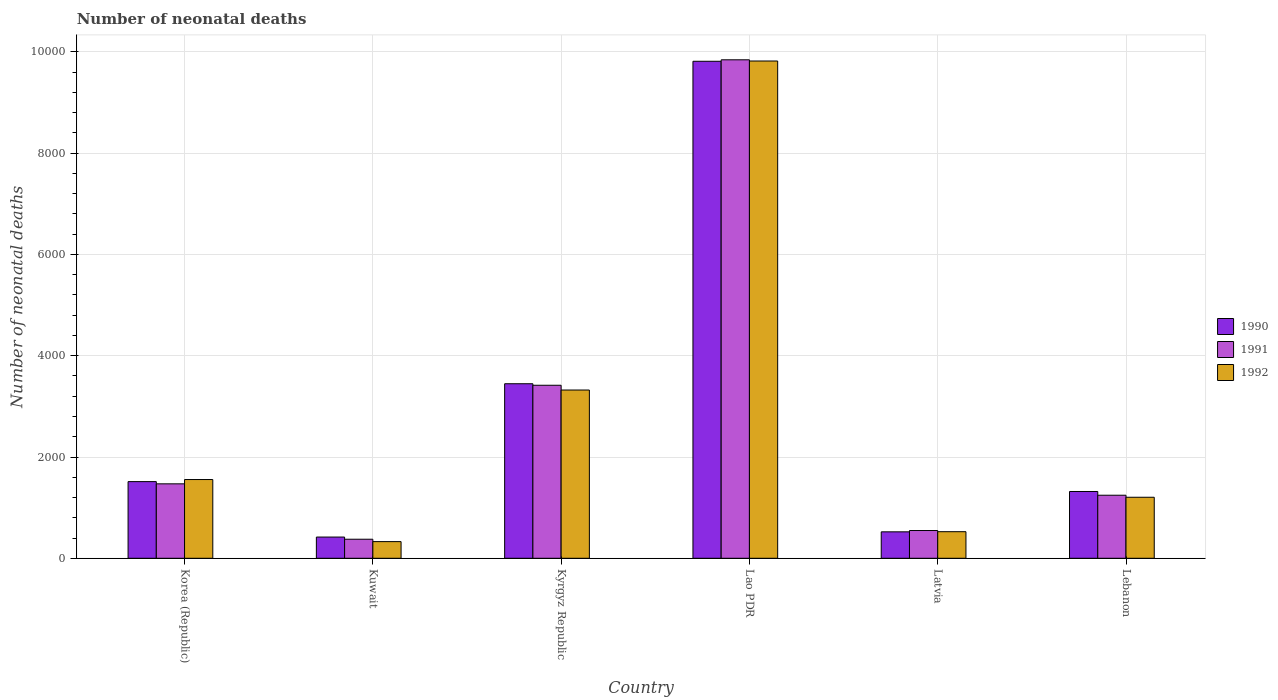How many different coloured bars are there?
Offer a terse response. 3. How many groups of bars are there?
Offer a terse response. 6. How many bars are there on the 4th tick from the left?
Make the answer very short. 3. How many bars are there on the 4th tick from the right?
Keep it short and to the point. 3. What is the label of the 5th group of bars from the left?
Your answer should be compact. Latvia. In how many cases, is the number of bars for a given country not equal to the number of legend labels?
Offer a terse response. 0. What is the number of neonatal deaths in in 1990 in Kyrgyz Republic?
Keep it short and to the point. 3447. Across all countries, what is the maximum number of neonatal deaths in in 1990?
Offer a very short reply. 9816. Across all countries, what is the minimum number of neonatal deaths in in 1992?
Your answer should be compact. 329. In which country was the number of neonatal deaths in in 1992 maximum?
Provide a short and direct response. Lao PDR. In which country was the number of neonatal deaths in in 1992 minimum?
Provide a short and direct response. Kuwait. What is the total number of neonatal deaths in in 1992 in the graph?
Keep it short and to the point. 1.68e+04. What is the difference between the number of neonatal deaths in in 1992 in Korea (Republic) and that in Latvia?
Offer a terse response. 1030. What is the difference between the number of neonatal deaths in in 1991 in Lao PDR and the number of neonatal deaths in in 1992 in Kyrgyz Republic?
Provide a succinct answer. 6522. What is the average number of neonatal deaths in in 1991 per country?
Provide a short and direct response. 2816.83. What is the difference between the number of neonatal deaths in of/in 1991 and number of neonatal deaths in of/in 1992 in Kyrgyz Republic?
Keep it short and to the point. 94. In how many countries, is the number of neonatal deaths in in 1992 greater than 4000?
Ensure brevity in your answer.  1. What is the ratio of the number of neonatal deaths in in 1990 in Korea (Republic) to that in Latvia?
Ensure brevity in your answer.  2.9. Is the difference between the number of neonatal deaths in in 1991 in Korea (Republic) and Kuwait greater than the difference between the number of neonatal deaths in in 1992 in Korea (Republic) and Kuwait?
Ensure brevity in your answer.  No. What is the difference between the highest and the second highest number of neonatal deaths in in 1990?
Keep it short and to the point. 8302. What is the difference between the highest and the lowest number of neonatal deaths in in 1991?
Provide a succinct answer. 9469. What does the 3rd bar from the right in Latvia represents?
Keep it short and to the point. 1990. Is it the case that in every country, the sum of the number of neonatal deaths in in 1990 and number of neonatal deaths in in 1992 is greater than the number of neonatal deaths in in 1991?
Your answer should be compact. Yes. How many bars are there?
Provide a succinct answer. 18. Are all the bars in the graph horizontal?
Your response must be concise. No. How many countries are there in the graph?
Your answer should be compact. 6. Does the graph contain any zero values?
Offer a terse response. No. What is the title of the graph?
Your answer should be compact. Number of neonatal deaths. Does "2006" appear as one of the legend labels in the graph?
Provide a short and direct response. No. What is the label or title of the X-axis?
Provide a succinct answer. Country. What is the label or title of the Y-axis?
Give a very brief answer. Number of neonatal deaths. What is the Number of neonatal deaths of 1990 in Korea (Republic)?
Make the answer very short. 1514. What is the Number of neonatal deaths in 1991 in Korea (Republic)?
Ensure brevity in your answer.  1470. What is the Number of neonatal deaths of 1992 in Korea (Republic)?
Provide a short and direct response. 1555. What is the Number of neonatal deaths of 1990 in Kuwait?
Ensure brevity in your answer.  419. What is the Number of neonatal deaths in 1991 in Kuwait?
Ensure brevity in your answer.  376. What is the Number of neonatal deaths in 1992 in Kuwait?
Offer a very short reply. 329. What is the Number of neonatal deaths of 1990 in Kyrgyz Republic?
Your answer should be very brief. 3447. What is the Number of neonatal deaths in 1991 in Kyrgyz Republic?
Your response must be concise. 3417. What is the Number of neonatal deaths of 1992 in Kyrgyz Republic?
Provide a short and direct response. 3323. What is the Number of neonatal deaths in 1990 in Lao PDR?
Provide a succinct answer. 9816. What is the Number of neonatal deaths in 1991 in Lao PDR?
Ensure brevity in your answer.  9845. What is the Number of neonatal deaths in 1992 in Lao PDR?
Provide a succinct answer. 9821. What is the Number of neonatal deaths in 1990 in Latvia?
Your response must be concise. 522. What is the Number of neonatal deaths in 1991 in Latvia?
Make the answer very short. 548. What is the Number of neonatal deaths in 1992 in Latvia?
Provide a short and direct response. 525. What is the Number of neonatal deaths in 1990 in Lebanon?
Make the answer very short. 1319. What is the Number of neonatal deaths of 1991 in Lebanon?
Provide a short and direct response. 1245. What is the Number of neonatal deaths of 1992 in Lebanon?
Offer a terse response. 1205. Across all countries, what is the maximum Number of neonatal deaths in 1990?
Your answer should be compact. 9816. Across all countries, what is the maximum Number of neonatal deaths in 1991?
Provide a succinct answer. 9845. Across all countries, what is the maximum Number of neonatal deaths in 1992?
Your answer should be very brief. 9821. Across all countries, what is the minimum Number of neonatal deaths in 1990?
Keep it short and to the point. 419. Across all countries, what is the minimum Number of neonatal deaths in 1991?
Give a very brief answer. 376. Across all countries, what is the minimum Number of neonatal deaths in 1992?
Offer a terse response. 329. What is the total Number of neonatal deaths in 1990 in the graph?
Your answer should be very brief. 1.70e+04. What is the total Number of neonatal deaths of 1991 in the graph?
Ensure brevity in your answer.  1.69e+04. What is the total Number of neonatal deaths in 1992 in the graph?
Your answer should be compact. 1.68e+04. What is the difference between the Number of neonatal deaths of 1990 in Korea (Republic) and that in Kuwait?
Keep it short and to the point. 1095. What is the difference between the Number of neonatal deaths in 1991 in Korea (Republic) and that in Kuwait?
Provide a succinct answer. 1094. What is the difference between the Number of neonatal deaths in 1992 in Korea (Republic) and that in Kuwait?
Ensure brevity in your answer.  1226. What is the difference between the Number of neonatal deaths of 1990 in Korea (Republic) and that in Kyrgyz Republic?
Make the answer very short. -1933. What is the difference between the Number of neonatal deaths of 1991 in Korea (Republic) and that in Kyrgyz Republic?
Offer a very short reply. -1947. What is the difference between the Number of neonatal deaths of 1992 in Korea (Republic) and that in Kyrgyz Republic?
Your answer should be compact. -1768. What is the difference between the Number of neonatal deaths of 1990 in Korea (Republic) and that in Lao PDR?
Your response must be concise. -8302. What is the difference between the Number of neonatal deaths in 1991 in Korea (Republic) and that in Lao PDR?
Offer a very short reply. -8375. What is the difference between the Number of neonatal deaths of 1992 in Korea (Republic) and that in Lao PDR?
Make the answer very short. -8266. What is the difference between the Number of neonatal deaths of 1990 in Korea (Republic) and that in Latvia?
Offer a very short reply. 992. What is the difference between the Number of neonatal deaths of 1991 in Korea (Republic) and that in Latvia?
Provide a succinct answer. 922. What is the difference between the Number of neonatal deaths in 1992 in Korea (Republic) and that in Latvia?
Your response must be concise. 1030. What is the difference between the Number of neonatal deaths in 1990 in Korea (Republic) and that in Lebanon?
Offer a very short reply. 195. What is the difference between the Number of neonatal deaths in 1991 in Korea (Republic) and that in Lebanon?
Give a very brief answer. 225. What is the difference between the Number of neonatal deaths of 1992 in Korea (Republic) and that in Lebanon?
Keep it short and to the point. 350. What is the difference between the Number of neonatal deaths of 1990 in Kuwait and that in Kyrgyz Republic?
Make the answer very short. -3028. What is the difference between the Number of neonatal deaths in 1991 in Kuwait and that in Kyrgyz Republic?
Your response must be concise. -3041. What is the difference between the Number of neonatal deaths in 1992 in Kuwait and that in Kyrgyz Republic?
Keep it short and to the point. -2994. What is the difference between the Number of neonatal deaths of 1990 in Kuwait and that in Lao PDR?
Give a very brief answer. -9397. What is the difference between the Number of neonatal deaths of 1991 in Kuwait and that in Lao PDR?
Give a very brief answer. -9469. What is the difference between the Number of neonatal deaths in 1992 in Kuwait and that in Lao PDR?
Your answer should be compact. -9492. What is the difference between the Number of neonatal deaths of 1990 in Kuwait and that in Latvia?
Offer a terse response. -103. What is the difference between the Number of neonatal deaths of 1991 in Kuwait and that in Latvia?
Make the answer very short. -172. What is the difference between the Number of neonatal deaths of 1992 in Kuwait and that in Latvia?
Ensure brevity in your answer.  -196. What is the difference between the Number of neonatal deaths in 1990 in Kuwait and that in Lebanon?
Ensure brevity in your answer.  -900. What is the difference between the Number of neonatal deaths of 1991 in Kuwait and that in Lebanon?
Your answer should be very brief. -869. What is the difference between the Number of neonatal deaths in 1992 in Kuwait and that in Lebanon?
Offer a very short reply. -876. What is the difference between the Number of neonatal deaths of 1990 in Kyrgyz Republic and that in Lao PDR?
Provide a short and direct response. -6369. What is the difference between the Number of neonatal deaths in 1991 in Kyrgyz Republic and that in Lao PDR?
Offer a very short reply. -6428. What is the difference between the Number of neonatal deaths of 1992 in Kyrgyz Republic and that in Lao PDR?
Keep it short and to the point. -6498. What is the difference between the Number of neonatal deaths of 1990 in Kyrgyz Republic and that in Latvia?
Ensure brevity in your answer.  2925. What is the difference between the Number of neonatal deaths in 1991 in Kyrgyz Republic and that in Latvia?
Provide a succinct answer. 2869. What is the difference between the Number of neonatal deaths in 1992 in Kyrgyz Republic and that in Latvia?
Your answer should be compact. 2798. What is the difference between the Number of neonatal deaths of 1990 in Kyrgyz Republic and that in Lebanon?
Make the answer very short. 2128. What is the difference between the Number of neonatal deaths of 1991 in Kyrgyz Republic and that in Lebanon?
Offer a very short reply. 2172. What is the difference between the Number of neonatal deaths in 1992 in Kyrgyz Republic and that in Lebanon?
Your answer should be compact. 2118. What is the difference between the Number of neonatal deaths in 1990 in Lao PDR and that in Latvia?
Provide a succinct answer. 9294. What is the difference between the Number of neonatal deaths in 1991 in Lao PDR and that in Latvia?
Make the answer very short. 9297. What is the difference between the Number of neonatal deaths of 1992 in Lao PDR and that in Latvia?
Your answer should be very brief. 9296. What is the difference between the Number of neonatal deaths of 1990 in Lao PDR and that in Lebanon?
Your response must be concise. 8497. What is the difference between the Number of neonatal deaths in 1991 in Lao PDR and that in Lebanon?
Your answer should be compact. 8600. What is the difference between the Number of neonatal deaths of 1992 in Lao PDR and that in Lebanon?
Offer a very short reply. 8616. What is the difference between the Number of neonatal deaths of 1990 in Latvia and that in Lebanon?
Keep it short and to the point. -797. What is the difference between the Number of neonatal deaths of 1991 in Latvia and that in Lebanon?
Your answer should be compact. -697. What is the difference between the Number of neonatal deaths of 1992 in Latvia and that in Lebanon?
Give a very brief answer. -680. What is the difference between the Number of neonatal deaths in 1990 in Korea (Republic) and the Number of neonatal deaths in 1991 in Kuwait?
Offer a very short reply. 1138. What is the difference between the Number of neonatal deaths in 1990 in Korea (Republic) and the Number of neonatal deaths in 1992 in Kuwait?
Keep it short and to the point. 1185. What is the difference between the Number of neonatal deaths of 1991 in Korea (Republic) and the Number of neonatal deaths of 1992 in Kuwait?
Give a very brief answer. 1141. What is the difference between the Number of neonatal deaths of 1990 in Korea (Republic) and the Number of neonatal deaths of 1991 in Kyrgyz Republic?
Provide a succinct answer. -1903. What is the difference between the Number of neonatal deaths of 1990 in Korea (Republic) and the Number of neonatal deaths of 1992 in Kyrgyz Republic?
Make the answer very short. -1809. What is the difference between the Number of neonatal deaths of 1991 in Korea (Republic) and the Number of neonatal deaths of 1992 in Kyrgyz Republic?
Your answer should be compact. -1853. What is the difference between the Number of neonatal deaths of 1990 in Korea (Republic) and the Number of neonatal deaths of 1991 in Lao PDR?
Your answer should be compact. -8331. What is the difference between the Number of neonatal deaths in 1990 in Korea (Republic) and the Number of neonatal deaths in 1992 in Lao PDR?
Keep it short and to the point. -8307. What is the difference between the Number of neonatal deaths of 1991 in Korea (Republic) and the Number of neonatal deaths of 1992 in Lao PDR?
Keep it short and to the point. -8351. What is the difference between the Number of neonatal deaths in 1990 in Korea (Republic) and the Number of neonatal deaths in 1991 in Latvia?
Make the answer very short. 966. What is the difference between the Number of neonatal deaths in 1990 in Korea (Republic) and the Number of neonatal deaths in 1992 in Latvia?
Keep it short and to the point. 989. What is the difference between the Number of neonatal deaths of 1991 in Korea (Republic) and the Number of neonatal deaths of 1992 in Latvia?
Your response must be concise. 945. What is the difference between the Number of neonatal deaths in 1990 in Korea (Republic) and the Number of neonatal deaths in 1991 in Lebanon?
Keep it short and to the point. 269. What is the difference between the Number of neonatal deaths in 1990 in Korea (Republic) and the Number of neonatal deaths in 1992 in Lebanon?
Provide a succinct answer. 309. What is the difference between the Number of neonatal deaths in 1991 in Korea (Republic) and the Number of neonatal deaths in 1992 in Lebanon?
Give a very brief answer. 265. What is the difference between the Number of neonatal deaths in 1990 in Kuwait and the Number of neonatal deaths in 1991 in Kyrgyz Republic?
Provide a short and direct response. -2998. What is the difference between the Number of neonatal deaths of 1990 in Kuwait and the Number of neonatal deaths of 1992 in Kyrgyz Republic?
Offer a very short reply. -2904. What is the difference between the Number of neonatal deaths of 1991 in Kuwait and the Number of neonatal deaths of 1992 in Kyrgyz Republic?
Your answer should be compact. -2947. What is the difference between the Number of neonatal deaths of 1990 in Kuwait and the Number of neonatal deaths of 1991 in Lao PDR?
Offer a terse response. -9426. What is the difference between the Number of neonatal deaths in 1990 in Kuwait and the Number of neonatal deaths in 1992 in Lao PDR?
Give a very brief answer. -9402. What is the difference between the Number of neonatal deaths of 1991 in Kuwait and the Number of neonatal deaths of 1992 in Lao PDR?
Offer a very short reply. -9445. What is the difference between the Number of neonatal deaths in 1990 in Kuwait and the Number of neonatal deaths in 1991 in Latvia?
Your response must be concise. -129. What is the difference between the Number of neonatal deaths of 1990 in Kuwait and the Number of neonatal deaths of 1992 in Latvia?
Your response must be concise. -106. What is the difference between the Number of neonatal deaths of 1991 in Kuwait and the Number of neonatal deaths of 1992 in Latvia?
Your answer should be very brief. -149. What is the difference between the Number of neonatal deaths in 1990 in Kuwait and the Number of neonatal deaths in 1991 in Lebanon?
Your response must be concise. -826. What is the difference between the Number of neonatal deaths in 1990 in Kuwait and the Number of neonatal deaths in 1992 in Lebanon?
Provide a short and direct response. -786. What is the difference between the Number of neonatal deaths in 1991 in Kuwait and the Number of neonatal deaths in 1992 in Lebanon?
Your answer should be very brief. -829. What is the difference between the Number of neonatal deaths in 1990 in Kyrgyz Republic and the Number of neonatal deaths in 1991 in Lao PDR?
Keep it short and to the point. -6398. What is the difference between the Number of neonatal deaths of 1990 in Kyrgyz Republic and the Number of neonatal deaths of 1992 in Lao PDR?
Provide a succinct answer. -6374. What is the difference between the Number of neonatal deaths of 1991 in Kyrgyz Republic and the Number of neonatal deaths of 1992 in Lao PDR?
Make the answer very short. -6404. What is the difference between the Number of neonatal deaths of 1990 in Kyrgyz Republic and the Number of neonatal deaths of 1991 in Latvia?
Your answer should be compact. 2899. What is the difference between the Number of neonatal deaths of 1990 in Kyrgyz Republic and the Number of neonatal deaths of 1992 in Latvia?
Provide a succinct answer. 2922. What is the difference between the Number of neonatal deaths in 1991 in Kyrgyz Republic and the Number of neonatal deaths in 1992 in Latvia?
Give a very brief answer. 2892. What is the difference between the Number of neonatal deaths in 1990 in Kyrgyz Republic and the Number of neonatal deaths in 1991 in Lebanon?
Provide a succinct answer. 2202. What is the difference between the Number of neonatal deaths of 1990 in Kyrgyz Republic and the Number of neonatal deaths of 1992 in Lebanon?
Provide a succinct answer. 2242. What is the difference between the Number of neonatal deaths of 1991 in Kyrgyz Republic and the Number of neonatal deaths of 1992 in Lebanon?
Provide a short and direct response. 2212. What is the difference between the Number of neonatal deaths in 1990 in Lao PDR and the Number of neonatal deaths in 1991 in Latvia?
Provide a short and direct response. 9268. What is the difference between the Number of neonatal deaths of 1990 in Lao PDR and the Number of neonatal deaths of 1992 in Latvia?
Offer a terse response. 9291. What is the difference between the Number of neonatal deaths of 1991 in Lao PDR and the Number of neonatal deaths of 1992 in Latvia?
Your response must be concise. 9320. What is the difference between the Number of neonatal deaths in 1990 in Lao PDR and the Number of neonatal deaths in 1991 in Lebanon?
Make the answer very short. 8571. What is the difference between the Number of neonatal deaths of 1990 in Lao PDR and the Number of neonatal deaths of 1992 in Lebanon?
Make the answer very short. 8611. What is the difference between the Number of neonatal deaths in 1991 in Lao PDR and the Number of neonatal deaths in 1992 in Lebanon?
Offer a terse response. 8640. What is the difference between the Number of neonatal deaths in 1990 in Latvia and the Number of neonatal deaths in 1991 in Lebanon?
Offer a very short reply. -723. What is the difference between the Number of neonatal deaths of 1990 in Latvia and the Number of neonatal deaths of 1992 in Lebanon?
Give a very brief answer. -683. What is the difference between the Number of neonatal deaths of 1991 in Latvia and the Number of neonatal deaths of 1992 in Lebanon?
Provide a succinct answer. -657. What is the average Number of neonatal deaths of 1990 per country?
Give a very brief answer. 2839.5. What is the average Number of neonatal deaths in 1991 per country?
Your answer should be compact. 2816.83. What is the average Number of neonatal deaths in 1992 per country?
Keep it short and to the point. 2793. What is the difference between the Number of neonatal deaths in 1990 and Number of neonatal deaths in 1992 in Korea (Republic)?
Provide a succinct answer. -41. What is the difference between the Number of neonatal deaths in 1991 and Number of neonatal deaths in 1992 in Korea (Republic)?
Offer a terse response. -85. What is the difference between the Number of neonatal deaths in 1991 and Number of neonatal deaths in 1992 in Kuwait?
Provide a succinct answer. 47. What is the difference between the Number of neonatal deaths in 1990 and Number of neonatal deaths in 1991 in Kyrgyz Republic?
Provide a succinct answer. 30. What is the difference between the Number of neonatal deaths of 1990 and Number of neonatal deaths of 1992 in Kyrgyz Republic?
Offer a terse response. 124. What is the difference between the Number of neonatal deaths of 1991 and Number of neonatal deaths of 1992 in Kyrgyz Republic?
Give a very brief answer. 94. What is the difference between the Number of neonatal deaths of 1990 and Number of neonatal deaths of 1991 in Lao PDR?
Offer a very short reply. -29. What is the difference between the Number of neonatal deaths in 1990 and Number of neonatal deaths in 1992 in Lao PDR?
Offer a terse response. -5. What is the difference between the Number of neonatal deaths of 1990 and Number of neonatal deaths of 1992 in Latvia?
Provide a succinct answer. -3. What is the difference between the Number of neonatal deaths of 1991 and Number of neonatal deaths of 1992 in Latvia?
Your answer should be very brief. 23. What is the difference between the Number of neonatal deaths of 1990 and Number of neonatal deaths of 1991 in Lebanon?
Make the answer very short. 74. What is the difference between the Number of neonatal deaths of 1990 and Number of neonatal deaths of 1992 in Lebanon?
Provide a short and direct response. 114. What is the ratio of the Number of neonatal deaths of 1990 in Korea (Republic) to that in Kuwait?
Your answer should be very brief. 3.61. What is the ratio of the Number of neonatal deaths of 1991 in Korea (Republic) to that in Kuwait?
Your response must be concise. 3.91. What is the ratio of the Number of neonatal deaths of 1992 in Korea (Republic) to that in Kuwait?
Ensure brevity in your answer.  4.73. What is the ratio of the Number of neonatal deaths of 1990 in Korea (Republic) to that in Kyrgyz Republic?
Offer a very short reply. 0.44. What is the ratio of the Number of neonatal deaths in 1991 in Korea (Republic) to that in Kyrgyz Republic?
Your response must be concise. 0.43. What is the ratio of the Number of neonatal deaths in 1992 in Korea (Republic) to that in Kyrgyz Republic?
Offer a terse response. 0.47. What is the ratio of the Number of neonatal deaths of 1990 in Korea (Republic) to that in Lao PDR?
Make the answer very short. 0.15. What is the ratio of the Number of neonatal deaths of 1991 in Korea (Republic) to that in Lao PDR?
Offer a very short reply. 0.15. What is the ratio of the Number of neonatal deaths of 1992 in Korea (Republic) to that in Lao PDR?
Your response must be concise. 0.16. What is the ratio of the Number of neonatal deaths of 1990 in Korea (Republic) to that in Latvia?
Give a very brief answer. 2.9. What is the ratio of the Number of neonatal deaths in 1991 in Korea (Republic) to that in Latvia?
Ensure brevity in your answer.  2.68. What is the ratio of the Number of neonatal deaths in 1992 in Korea (Republic) to that in Latvia?
Make the answer very short. 2.96. What is the ratio of the Number of neonatal deaths in 1990 in Korea (Republic) to that in Lebanon?
Give a very brief answer. 1.15. What is the ratio of the Number of neonatal deaths of 1991 in Korea (Republic) to that in Lebanon?
Make the answer very short. 1.18. What is the ratio of the Number of neonatal deaths in 1992 in Korea (Republic) to that in Lebanon?
Your answer should be compact. 1.29. What is the ratio of the Number of neonatal deaths in 1990 in Kuwait to that in Kyrgyz Republic?
Provide a short and direct response. 0.12. What is the ratio of the Number of neonatal deaths of 1991 in Kuwait to that in Kyrgyz Republic?
Provide a succinct answer. 0.11. What is the ratio of the Number of neonatal deaths in 1992 in Kuwait to that in Kyrgyz Republic?
Keep it short and to the point. 0.1. What is the ratio of the Number of neonatal deaths in 1990 in Kuwait to that in Lao PDR?
Ensure brevity in your answer.  0.04. What is the ratio of the Number of neonatal deaths of 1991 in Kuwait to that in Lao PDR?
Offer a terse response. 0.04. What is the ratio of the Number of neonatal deaths in 1992 in Kuwait to that in Lao PDR?
Make the answer very short. 0.03. What is the ratio of the Number of neonatal deaths of 1990 in Kuwait to that in Latvia?
Provide a succinct answer. 0.8. What is the ratio of the Number of neonatal deaths of 1991 in Kuwait to that in Latvia?
Ensure brevity in your answer.  0.69. What is the ratio of the Number of neonatal deaths of 1992 in Kuwait to that in Latvia?
Ensure brevity in your answer.  0.63. What is the ratio of the Number of neonatal deaths in 1990 in Kuwait to that in Lebanon?
Keep it short and to the point. 0.32. What is the ratio of the Number of neonatal deaths in 1991 in Kuwait to that in Lebanon?
Your answer should be compact. 0.3. What is the ratio of the Number of neonatal deaths of 1992 in Kuwait to that in Lebanon?
Give a very brief answer. 0.27. What is the ratio of the Number of neonatal deaths of 1990 in Kyrgyz Republic to that in Lao PDR?
Give a very brief answer. 0.35. What is the ratio of the Number of neonatal deaths in 1991 in Kyrgyz Republic to that in Lao PDR?
Give a very brief answer. 0.35. What is the ratio of the Number of neonatal deaths of 1992 in Kyrgyz Republic to that in Lao PDR?
Your response must be concise. 0.34. What is the ratio of the Number of neonatal deaths of 1990 in Kyrgyz Republic to that in Latvia?
Provide a short and direct response. 6.6. What is the ratio of the Number of neonatal deaths in 1991 in Kyrgyz Republic to that in Latvia?
Keep it short and to the point. 6.24. What is the ratio of the Number of neonatal deaths in 1992 in Kyrgyz Republic to that in Latvia?
Ensure brevity in your answer.  6.33. What is the ratio of the Number of neonatal deaths in 1990 in Kyrgyz Republic to that in Lebanon?
Provide a succinct answer. 2.61. What is the ratio of the Number of neonatal deaths in 1991 in Kyrgyz Republic to that in Lebanon?
Offer a terse response. 2.74. What is the ratio of the Number of neonatal deaths of 1992 in Kyrgyz Republic to that in Lebanon?
Your response must be concise. 2.76. What is the ratio of the Number of neonatal deaths in 1990 in Lao PDR to that in Latvia?
Give a very brief answer. 18.8. What is the ratio of the Number of neonatal deaths in 1991 in Lao PDR to that in Latvia?
Offer a terse response. 17.97. What is the ratio of the Number of neonatal deaths in 1992 in Lao PDR to that in Latvia?
Keep it short and to the point. 18.71. What is the ratio of the Number of neonatal deaths of 1990 in Lao PDR to that in Lebanon?
Your response must be concise. 7.44. What is the ratio of the Number of neonatal deaths in 1991 in Lao PDR to that in Lebanon?
Offer a very short reply. 7.91. What is the ratio of the Number of neonatal deaths of 1992 in Lao PDR to that in Lebanon?
Offer a very short reply. 8.15. What is the ratio of the Number of neonatal deaths in 1990 in Latvia to that in Lebanon?
Give a very brief answer. 0.4. What is the ratio of the Number of neonatal deaths of 1991 in Latvia to that in Lebanon?
Your answer should be very brief. 0.44. What is the ratio of the Number of neonatal deaths in 1992 in Latvia to that in Lebanon?
Offer a terse response. 0.44. What is the difference between the highest and the second highest Number of neonatal deaths in 1990?
Offer a terse response. 6369. What is the difference between the highest and the second highest Number of neonatal deaths in 1991?
Offer a terse response. 6428. What is the difference between the highest and the second highest Number of neonatal deaths in 1992?
Offer a terse response. 6498. What is the difference between the highest and the lowest Number of neonatal deaths in 1990?
Offer a terse response. 9397. What is the difference between the highest and the lowest Number of neonatal deaths of 1991?
Offer a very short reply. 9469. What is the difference between the highest and the lowest Number of neonatal deaths of 1992?
Your answer should be very brief. 9492. 